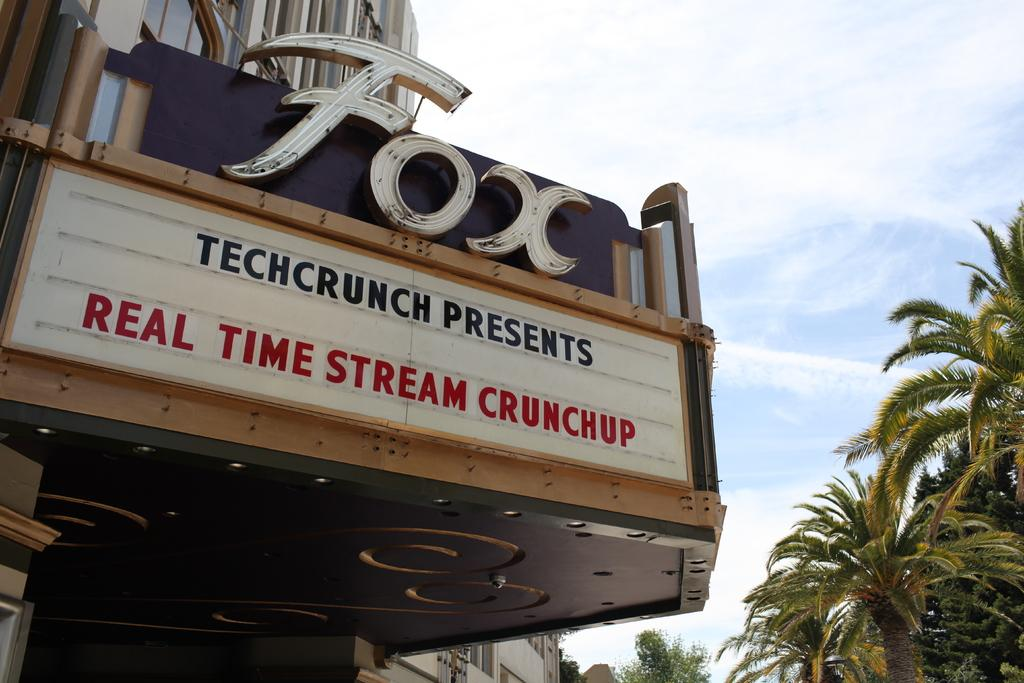What is the main structure in the center of the image? There is a building in the center of the image. What can be seen on the wall of the building? There is text on a wall in the image. What type of vegetation is on the right side of the image? There are trees on the right side of the image. What is visible at the top of the image? The sky is visible at the top of the image. Can you see a pencil being used by someone in the image? There is no pencil or person using a pencil in the image. How many chickens are present in the image? There are no chickens present in the image. 